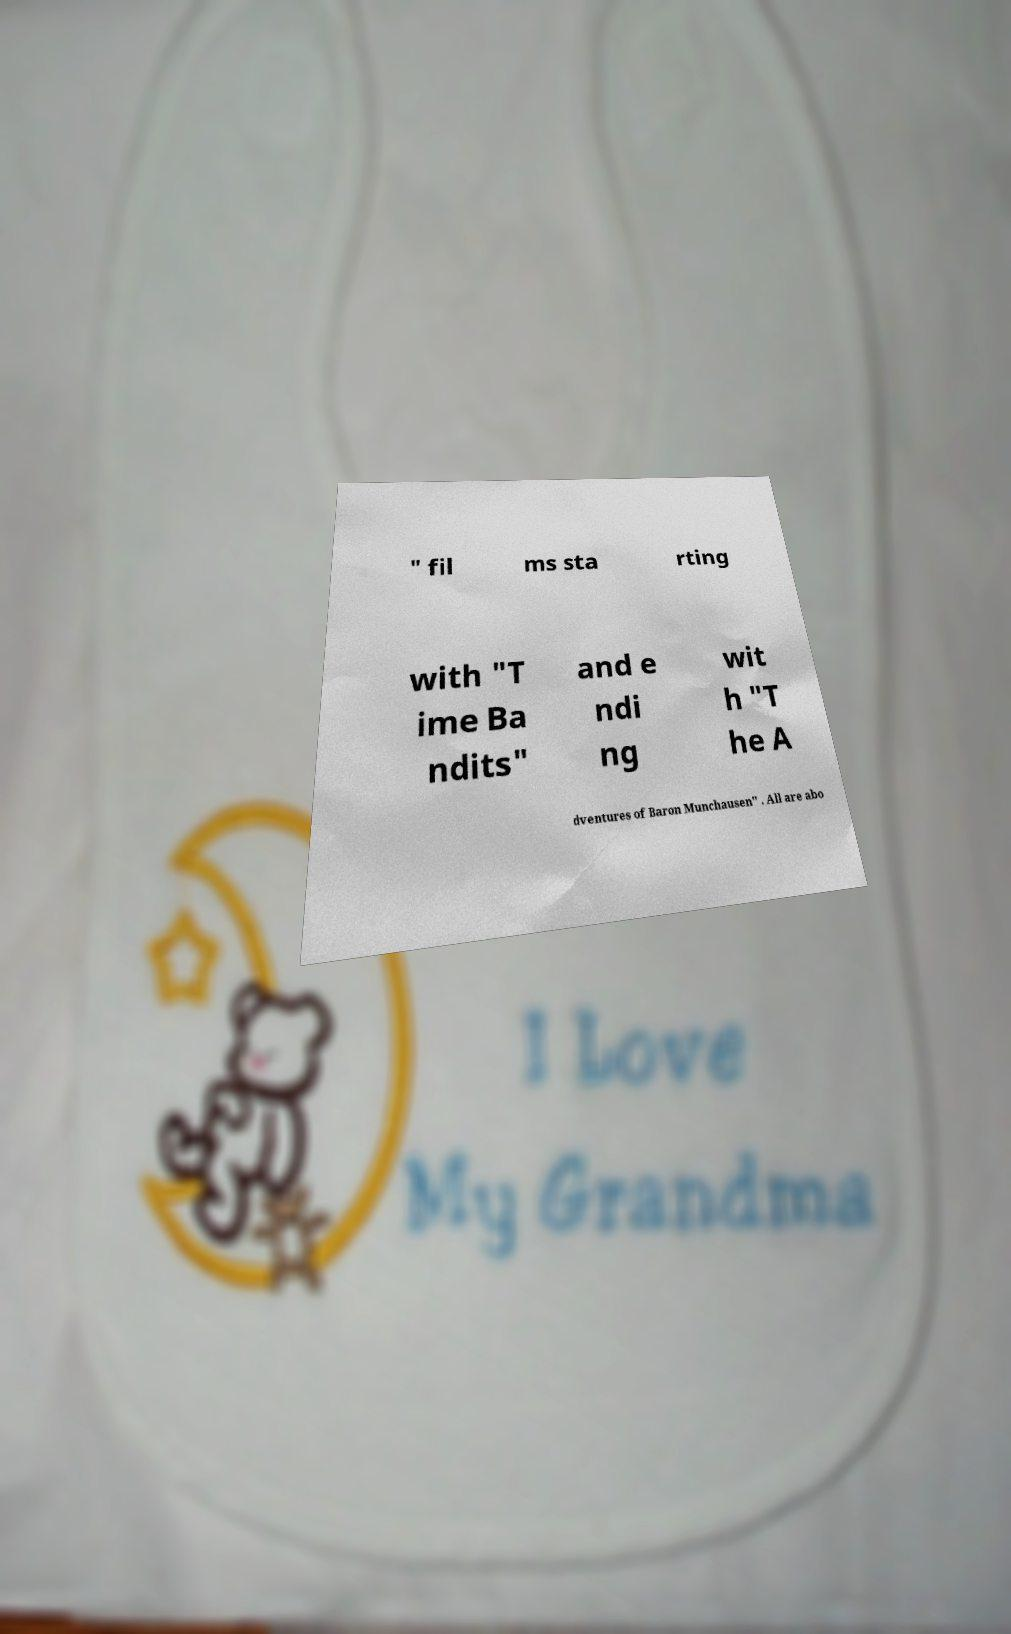Please read and relay the text visible in this image. What does it say? " fil ms sta rting with "T ime Ba ndits" and e ndi ng wit h "T he A dventures of Baron Munchausen" . All are abo 